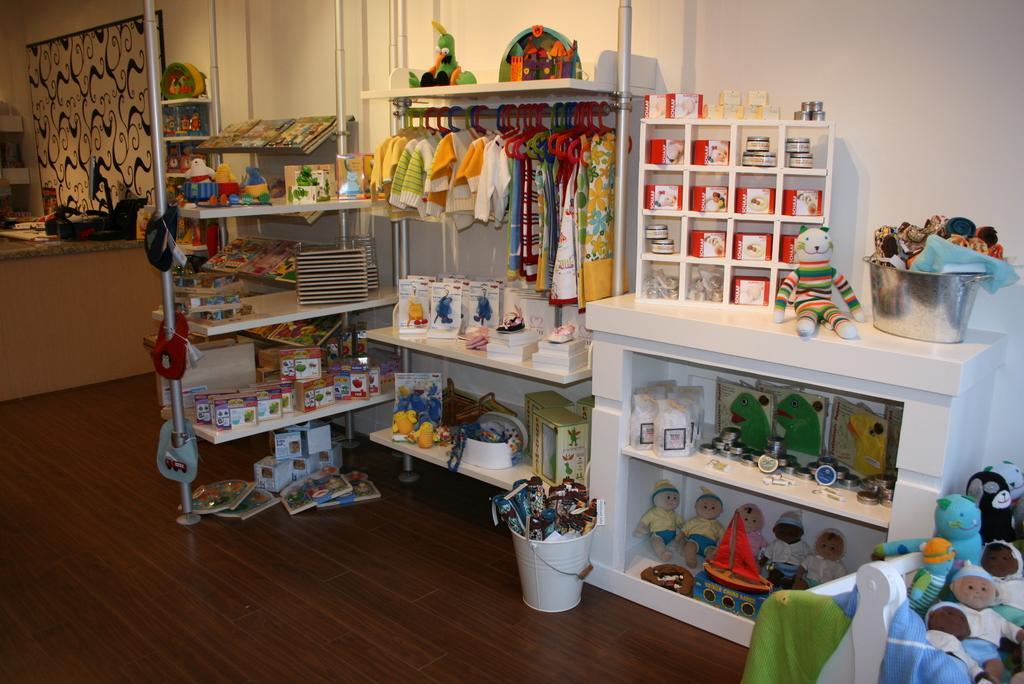In one or two sentences, can you explain what this image depicts? In this image I can see the brown colored surface on which I can see a white colored bucket with few object in it, a rack with few object in the rack, few clothes, few hangers, few toys in the cupboard, a container with few object in it. In the background I can see the wall, the curtain and few other objects. 